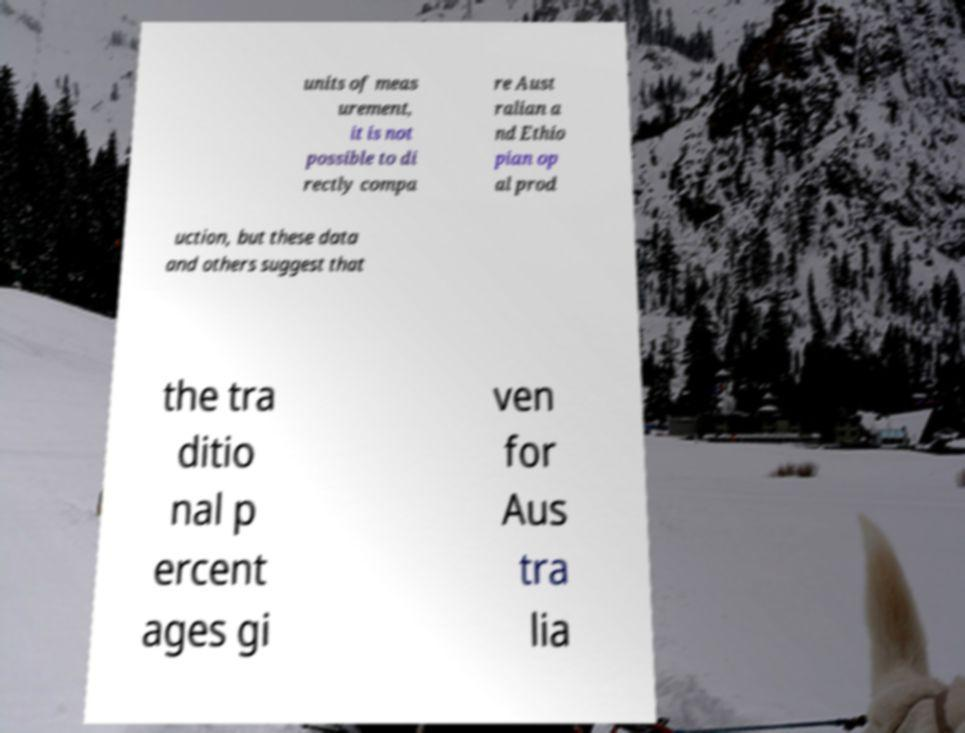Could you extract and type out the text from this image? units of meas urement, it is not possible to di rectly compa re Aust ralian a nd Ethio pian op al prod uction, but these data and others suggest that the tra ditio nal p ercent ages gi ven for Aus tra lia 